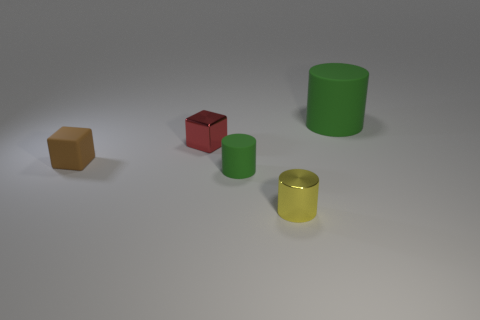Add 4 small brown rubber blocks. How many objects exist? 9 Subtract all cylinders. How many objects are left? 2 Add 5 tiny rubber cubes. How many tiny rubber cubes exist? 6 Subtract 0 purple spheres. How many objects are left? 5 Subtract all gray cubes. Subtract all shiny cylinders. How many objects are left? 4 Add 2 tiny matte cubes. How many tiny matte cubes are left? 3 